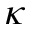<formula> <loc_0><loc_0><loc_500><loc_500>\kappa</formula> 